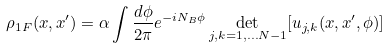Convert formula to latex. <formula><loc_0><loc_0><loc_500><loc_500>\rho _ { 1 F } ( x , x ^ { \prime } ) = \alpha \int \frac { d \phi } { 2 \pi } e ^ { - i N _ { B } \phi } \det _ { j , k = 1 , \dots N - 1 } [ u _ { j , k } ( x , x ^ { \prime } , \phi ) ]</formula> 